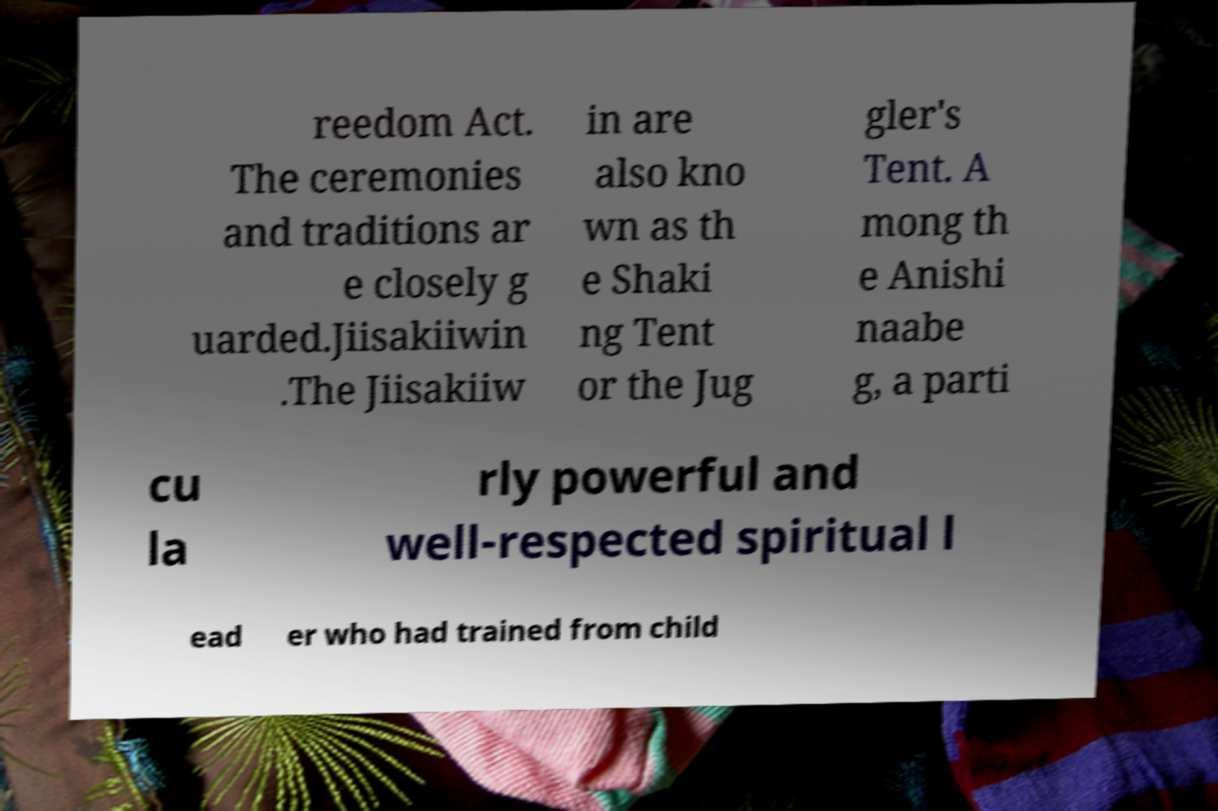I need the written content from this picture converted into text. Can you do that? reedom Act. The ceremonies and traditions ar e closely g uarded.Jiisakiiwin .The Jiisakiiw in are also kno wn as th e Shaki ng Tent or the Jug gler's Tent. A mong th e Anishi naabe g, a parti cu la rly powerful and well-respected spiritual l ead er who had trained from child 